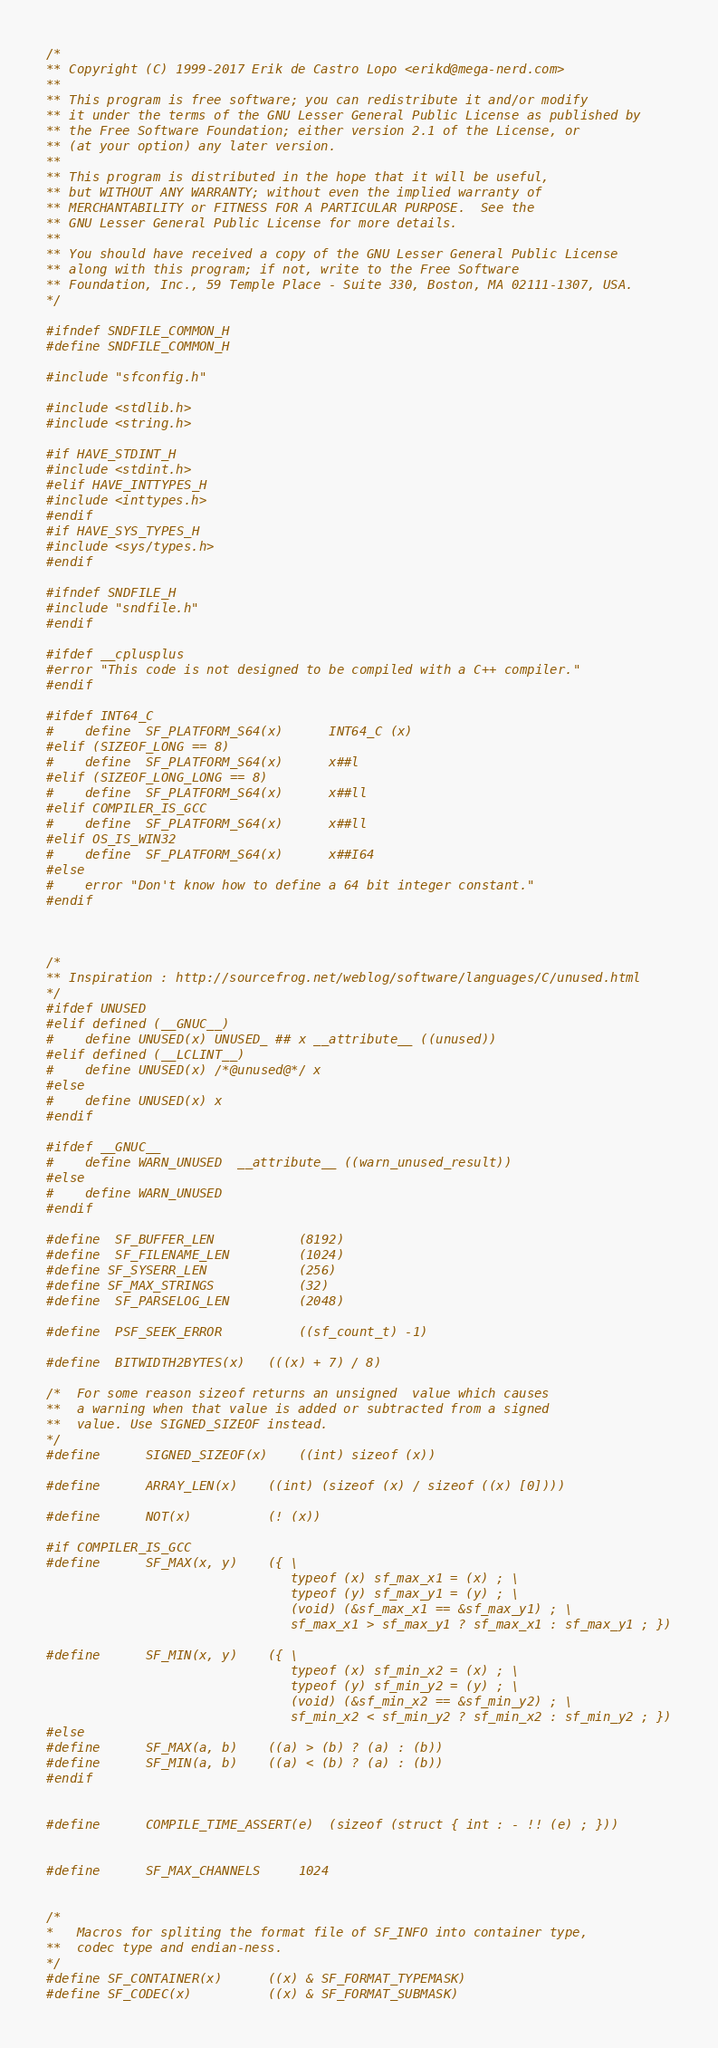<code> <loc_0><loc_0><loc_500><loc_500><_C_>/*
** Copyright (C) 1999-2017 Erik de Castro Lopo <erikd@mega-nerd.com>
**
** This program is free software; you can redistribute it and/or modify
** it under the terms of the GNU Lesser General Public License as published by
** the Free Software Foundation; either version 2.1 of the License, or
** (at your option) any later version.
**
** This program is distributed in the hope that it will be useful,
** but WITHOUT ANY WARRANTY; without even the implied warranty of
** MERCHANTABILITY or FITNESS FOR A PARTICULAR PURPOSE.  See the
** GNU Lesser General Public License for more details.
**
** You should have received a copy of the GNU Lesser General Public License
** along with this program; if not, write to the Free Software
** Foundation, Inc., 59 Temple Place - Suite 330, Boston, MA 02111-1307, USA.
*/

#ifndef SNDFILE_COMMON_H
#define SNDFILE_COMMON_H

#include "sfconfig.h"

#include <stdlib.h>
#include <string.h>

#if HAVE_STDINT_H
#include <stdint.h>
#elif HAVE_INTTYPES_H
#include <inttypes.h>
#endif
#if HAVE_SYS_TYPES_H
#include <sys/types.h>
#endif

#ifndef SNDFILE_H
#include "sndfile.h"
#endif

#ifdef __cplusplus
#error "This code is not designed to be compiled with a C++ compiler."
#endif

#ifdef INT64_C
#	define	SF_PLATFORM_S64(x)		INT64_C (x)
#elif (SIZEOF_LONG == 8)
#	define	SF_PLATFORM_S64(x)		x##l
#elif (SIZEOF_LONG_LONG == 8)
#	define	SF_PLATFORM_S64(x)		x##ll
#elif COMPILER_IS_GCC
#	define	SF_PLATFORM_S64(x)		x##ll
#elif OS_IS_WIN32
#	define	SF_PLATFORM_S64(x)		x##I64
#else
#	error "Don't know how to define a 64 bit integer constant."
#endif



/*
** Inspiration : http://sourcefrog.net/weblog/software/languages/C/unused.html
*/
#ifdef UNUSED
#elif defined (__GNUC__)
#	define UNUSED(x) UNUSED_ ## x __attribute__ ((unused))
#elif defined (__LCLINT__)
#	define UNUSED(x) /*@unused@*/ x
#else
#	define UNUSED(x) x
#endif

#ifdef __GNUC__
#	define WARN_UNUSED	__attribute__ ((warn_unused_result))
#else
#	define WARN_UNUSED
#endif

#define	SF_BUFFER_LEN			(8192)
#define	SF_FILENAME_LEN			(1024)
#define SF_SYSERR_LEN			(256)
#define SF_MAX_STRINGS			(32)
#define	SF_PARSELOG_LEN			(2048)

#define	PSF_SEEK_ERROR			((sf_count_t) -1)

#define	BITWIDTH2BYTES(x)	(((x) + 7) / 8)

/*	For some reason sizeof returns an unsigned  value which causes
**	a warning when that value is added or subtracted from a signed
**	value. Use SIGNED_SIZEOF instead.
*/
#define		SIGNED_SIZEOF(x)	((int) sizeof (x))

#define		ARRAY_LEN(x)	((int) (sizeof (x) / sizeof ((x) [0])))

#define		NOT(x)			(! (x))

#if COMPILER_IS_GCC
#define		SF_MAX(x, y)	({ \
								typeof (x) sf_max_x1 = (x) ; \
								typeof (y) sf_max_y1 = (y) ; \
								(void) (&sf_max_x1 == &sf_max_y1) ; \
								sf_max_x1 > sf_max_y1 ? sf_max_x1 : sf_max_y1 ; })

#define		SF_MIN(x, y)	({ \
								typeof (x) sf_min_x2 = (x) ; \
								typeof (y) sf_min_y2 = (y) ; \
								(void) (&sf_min_x2 == &sf_min_y2) ; \
								sf_min_x2 < sf_min_y2 ? sf_min_x2 : sf_min_y2 ; })
#else
#define		SF_MAX(a, b)	((a) > (b) ? (a) : (b))
#define		SF_MIN(a, b)	((a) < (b) ? (a) : (b))
#endif


#define		COMPILE_TIME_ASSERT(e)	(sizeof (struct { int : - !! (e) ; }))


#define		SF_MAX_CHANNELS		1024


/*
*	Macros for spliting the format file of SF_INFO into container type,
**	codec type and endian-ness.
*/
#define SF_CONTAINER(x)		((x) & SF_FORMAT_TYPEMASK)
#define SF_CODEC(x)			((x) & SF_FORMAT_SUBMASK)</code> 